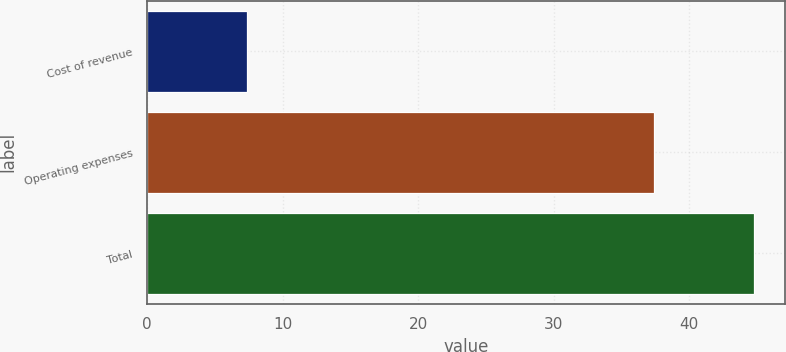Convert chart. <chart><loc_0><loc_0><loc_500><loc_500><bar_chart><fcel>Cost of revenue<fcel>Operating expenses<fcel>Total<nl><fcel>7.4<fcel>37.4<fcel>44.8<nl></chart> 